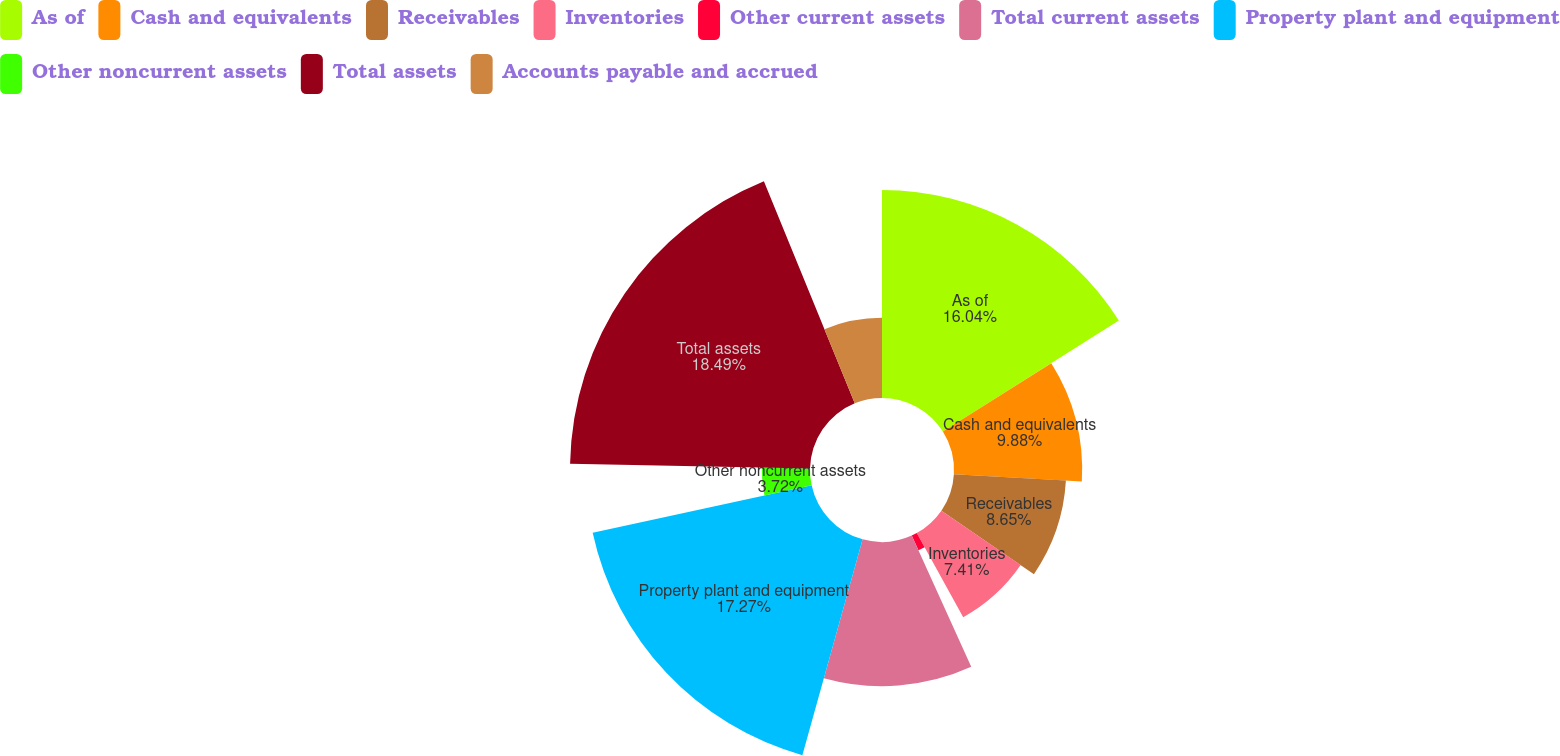Convert chart. <chart><loc_0><loc_0><loc_500><loc_500><pie_chart><fcel>As of<fcel>Cash and equivalents<fcel>Receivables<fcel>Inventories<fcel>Other current assets<fcel>Total current assets<fcel>Property plant and equipment<fcel>Other noncurrent assets<fcel>Total assets<fcel>Accounts payable and accrued<nl><fcel>16.04%<fcel>9.88%<fcel>8.65%<fcel>7.41%<fcel>1.25%<fcel>11.11%<fcel>17.27%<fcel>3.72%<fcel>18.5%<fcel>6.18%<nl></chart> 